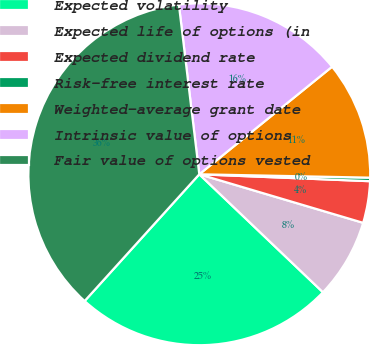Convert chart. <chart><loc_0><loc_0><loc_500><loc_500><pie_chart><fcel>Expected volatility<fcel>Expected life of options (in<fcel>Expected dividend rate<fcel>Risk-free interest rate<fcel>Weighted-average grant date<fcel>Intrinsic value of options<fcel>Fair value of options vested<nl><fcel>24.58%<fcel>7.54%<fcel>3.94%<fcel>0.33%<fcel>11.15%<fcel>16.07%<fcel>36.39%<nl></chart> 